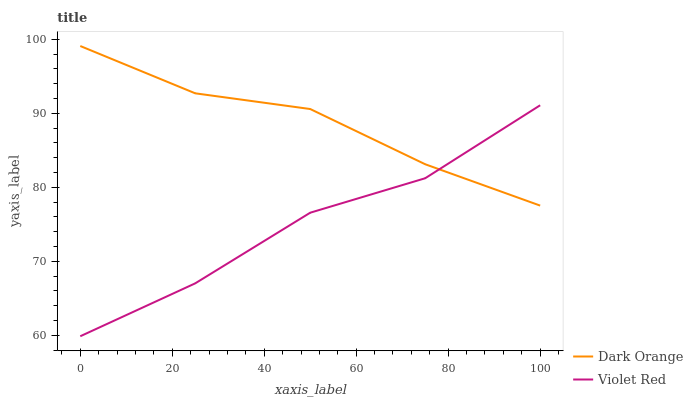Does Violet Red have the minimum area under the curve?
Answer yes or no. Yes. Does Dark Orange have the maximum area under the curve?
Answer yes or no. Yes. Does Violet Red have the maximum area under the curve?
Answer yes or no. No. Is Dark Orange the smoothest?
Answer yes or no. Yes. Is Violet Red the roughest?
Answer yes or no. Yes. Is Violet Red the smoothest?
Answer yes or no. No. Does Violet Red have the lowest value?
Answer yes or no. Yes. Does Dark Orange have the highest value?
Answer yes or no. Yes. Does Violet Red have the highest value?
Answer yes or no. No. Does Violet Red intersect Dark Orange?
Answer yes or no. Yes. Is Violet Red less than Dark Orange?
Answer yes or no. No. Is Violet Red greater than Dark Orange?
Answer yes or no. No. 